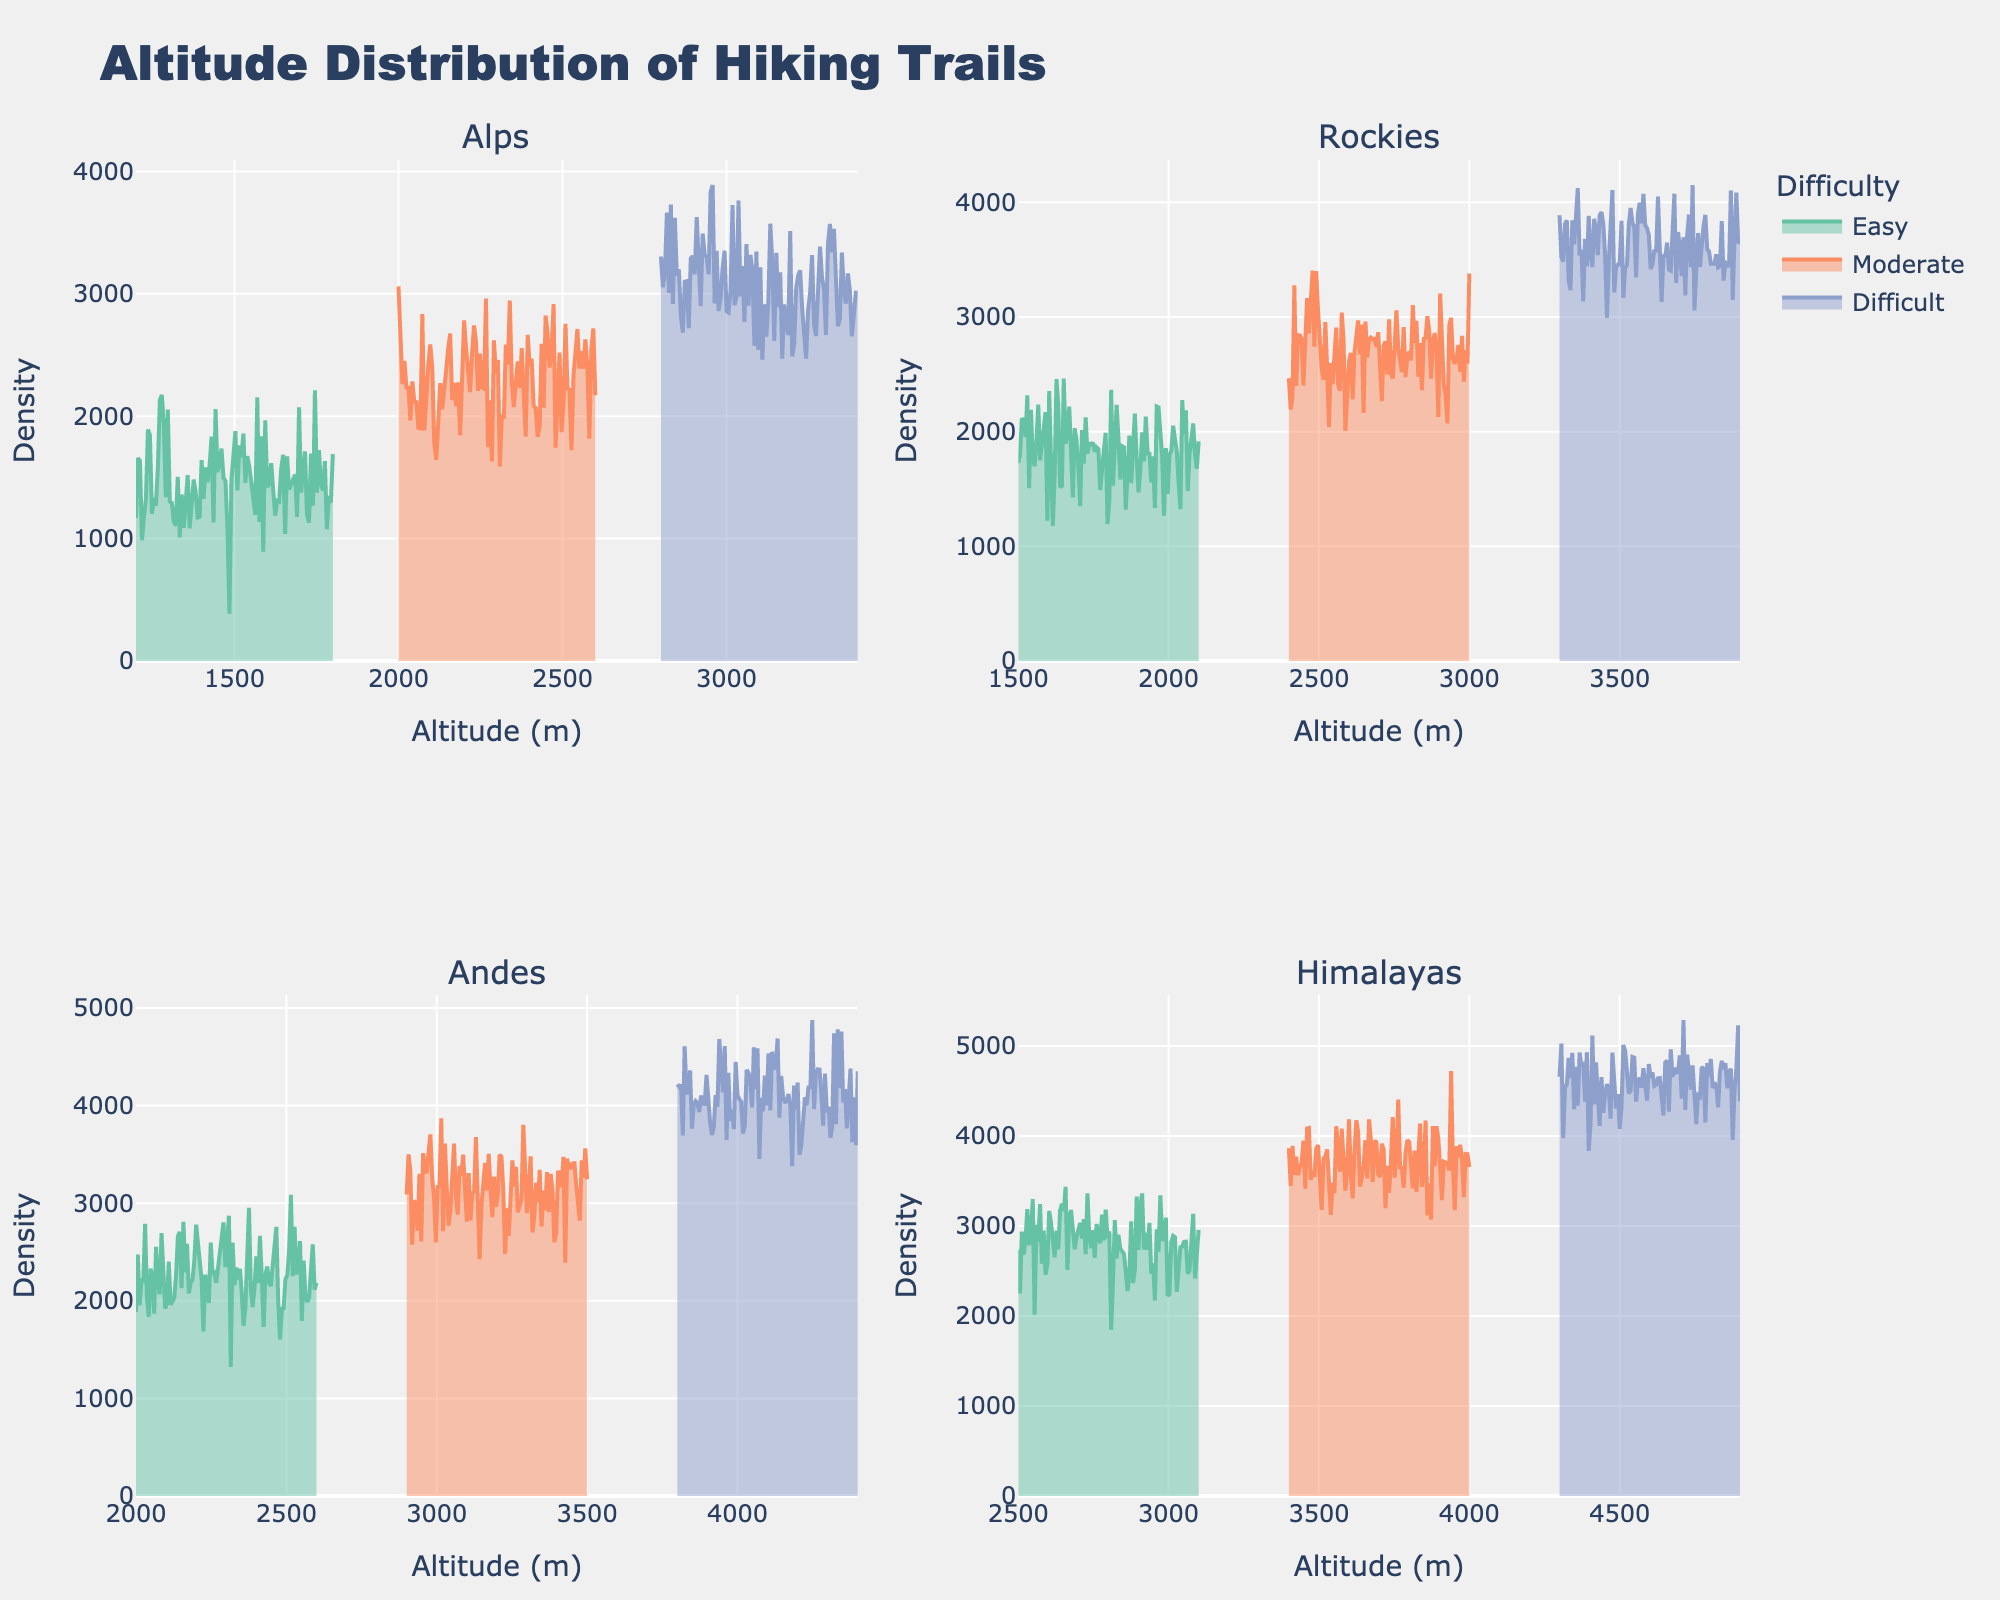What's the title of the figure? The title of the figure is often prominently displayed at the top of the plot. In this figure, the title describes the main topic of the visualization which is the "Altitude Distribution of Hiking Trails".
Answer: Altitude Distribution of Hiking Trails What are the x-axis and y-axis titles? The x-axis and y-axis titles are labeled to indicate what each axis represents. In this case, the x-axis is labeled "Altitude (m)" and the y-axis is labeled "Density".
Answer: Altitude (m) and Density What are the different difficulty levels represented in the figure? The different difficulty levels are represented by different colors in the plot. According to the legend, the difficulty levels are Easy, Moderate, and Difficult.
Answer: Easy, Moderate, Difficult In which mountain range does the 'Difficult' category have the highest altitude density distribution? To determine the mountain range with the highest altitude density distribution for the 'Difficult' category, we need to look at the peak of the density plot for the 'Difficult' category in each subplot. By comparing the highest peak, we can find that the Himalayas have the highest peak.
Answer: Himalayas Which mountain range has the highest density of 'Easy' trails? By inspecting the peak of the density plots for the 'Easy' trails in each subplot, we can find that the Himalayas have the highest density for the 'Easy' trails as the peak is the tallest in that subplot compared to others.
Answer: Himalayas How do the altitude distributions of 'Moderate' trails compare between the Alps and the Rockies? We directly compare the density plots for 'Moderate' trails between the Alps and the Rockies subplots. The Rockies appear to have a higher mean altitude and a wider spread compared to the Alps.
Answer: The Rockies have a higher mean altitude and a wider spread In the Andes, which difficulty level has the widest spread in altitude? To find the difficulty level with the widest spread in altitude, we look at the range and shape of the density plots in the Andes subplot. The 'Difficult' trails have the widest spread as the plot spans a larger range of altitudes.
Answer: Difficult Which difficulty level in the Rockies has the smallest range of altitudes? We identify the difficulty level with the smallest range by comparing the spans of the density plots in the Rockies subplot. The 'Easy' difficulty level has the smallest range in this case.
Answer: Easy What is the relationship between altitude and difficulty level evident in these plots? Observing the plots collectively, it is clear that as the difficulty level increases, the mean altitude also tends to increase. This trend is evident across all mountain ranges.
Answer: Higher difficulty levels generally correlate with higher altitudes 